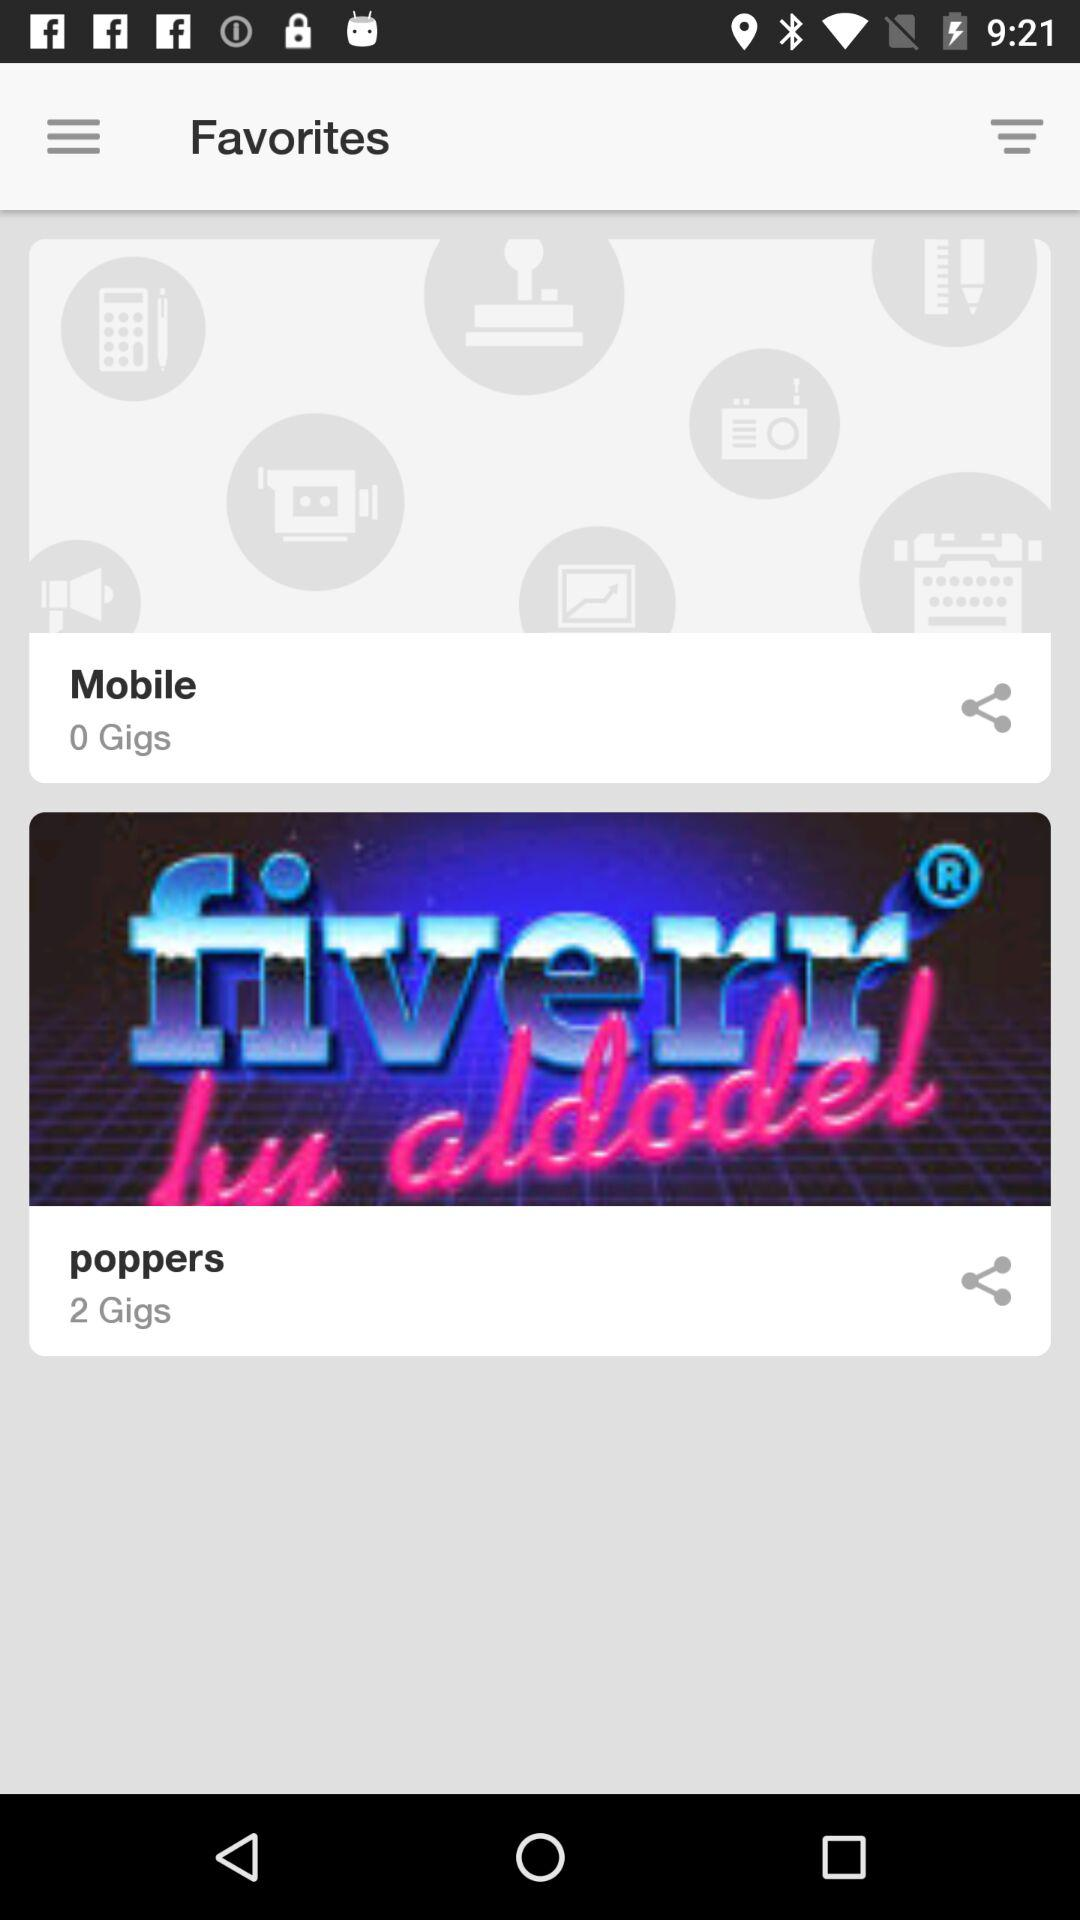How many gigs are there in "poppers"? There are 2 gigs in "poppers". 